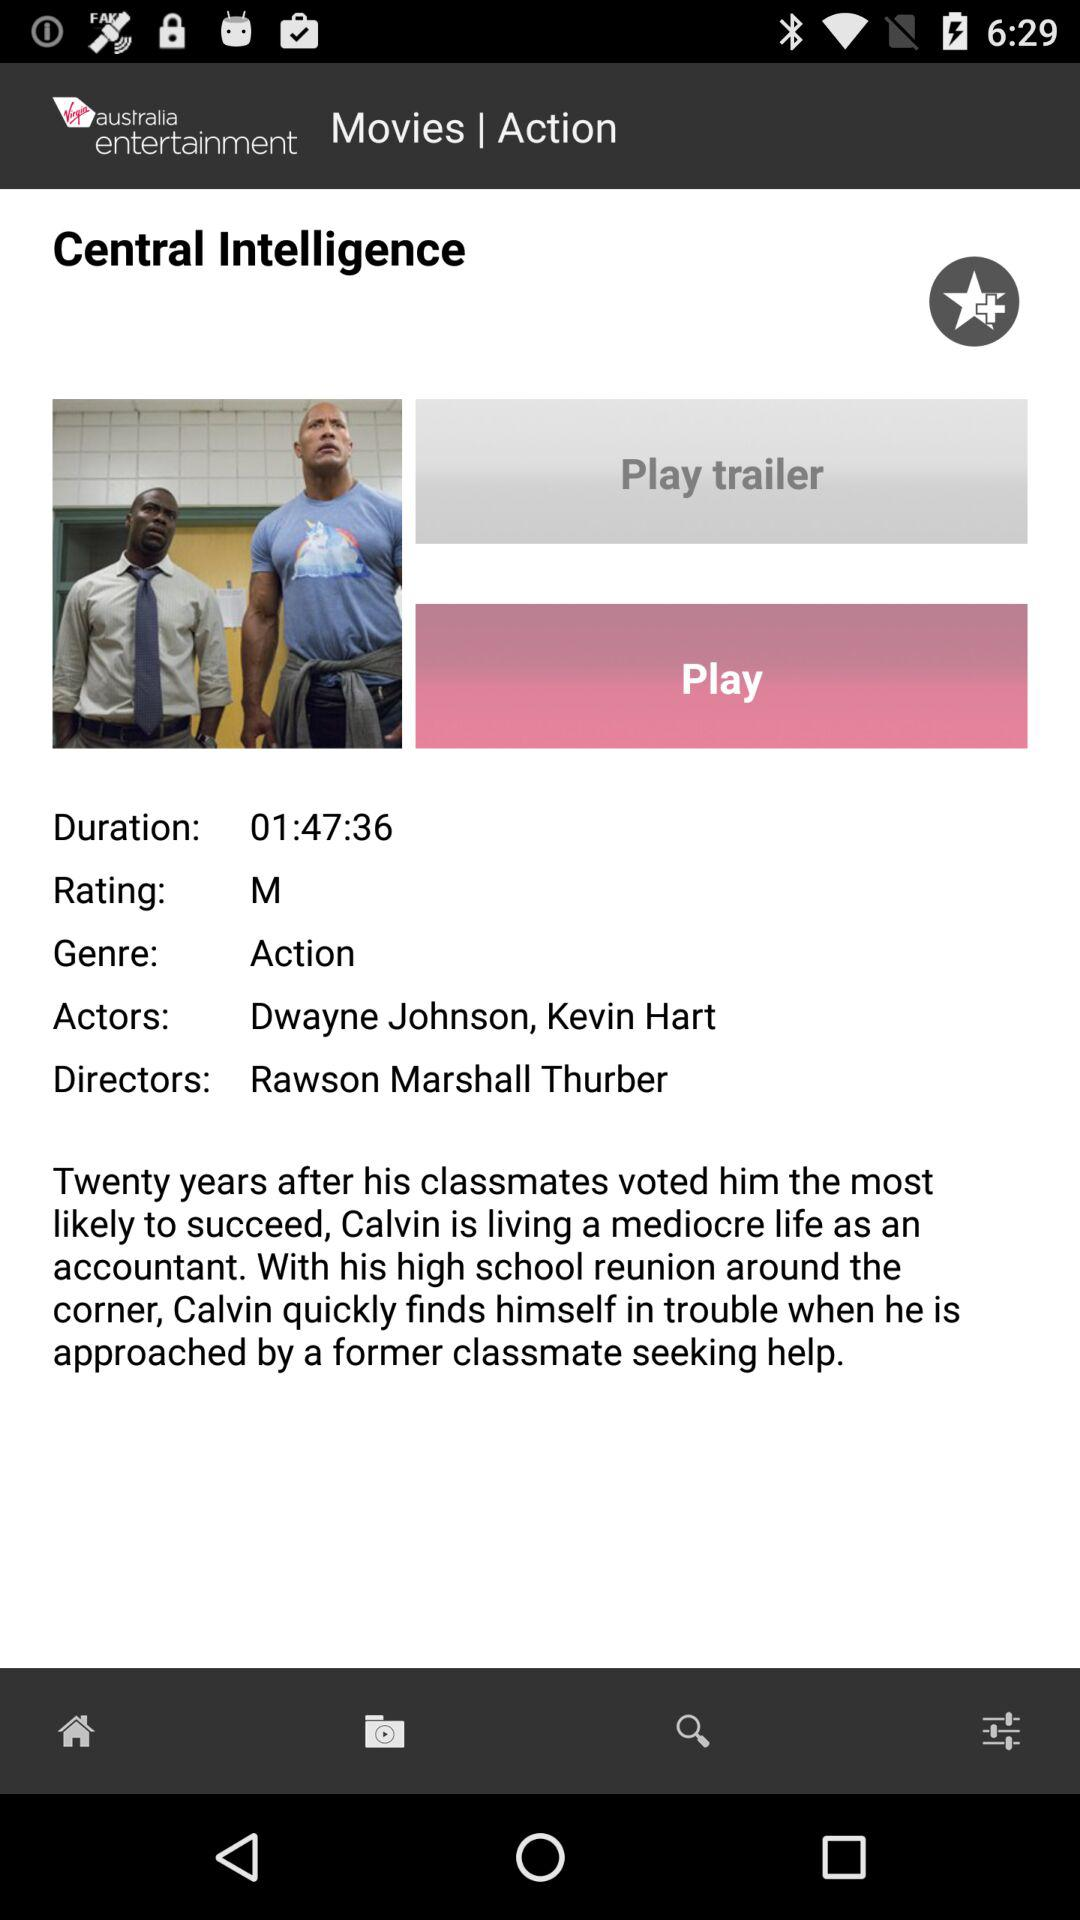Who is the director of the movie? The director of the movie is Rawson Marshall Thurber. 